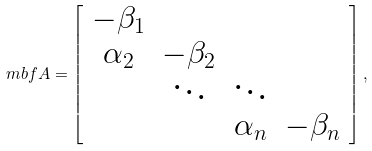Convert formula to latex. <formula><loc_0><loc_0><loc_500><loc_500>\ m b f { A } = \left [ \begin{array} { c c c c } - \beta _ { 1 } & & & \\ \alpha _ { 2 } & - \beta _ { 2 } & & \\ & \ddots & \ddots & \\ & & \alpha _ { n } & - \beta _ { n } \end{array} \right ] ,</formula> 